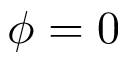<formula> <loc_0><loc_0><loc_500><loc_500>\phi = 0</formula> 